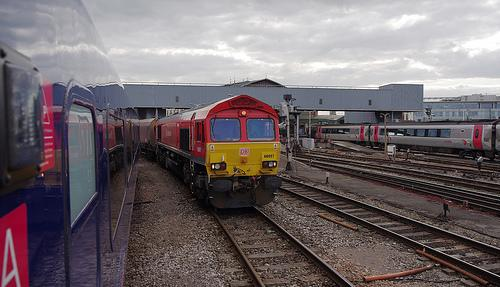List down at least three objects in the image that are associated with the train tracks. Rocks on the track, sets of train tracks, and stones around the tracks. What can be said about the positioning of the trains in the image? Many trains are in the station, with three of them visible in the image. Identify an object in the image that is turned on. The lights on the side of the train are turned on. What type of building is depicted in the image? A long building over the train tracks, which appears to be a train station. What is the primary object in the picture and what is its color? The primary object in the image is a red and yellow train. Count the number of train tracks visible in the image. There are multiple sets of train tracks in the station. Can you describe any distinct feature or detail related to the train's appearance? The train has a pair of small headlights and red doors. Explain the location of the red object in the image. The red object is a door located on the side of the train. In a few words, describe the weather conditions depicted in the image. The weather in the image is overcast with a very cloudy grey sky. In a brief sentence, describe the overall sentiment or mood of the image. The image captures a busy train station on an overcast day. Are the lights on the side of the train off? There is a mention of the lights on the side being on, but no mentions of the lights being off. Is the train blue and green? There are several mentions of the train being red and yellow, but none of the train being blue and green. Is there only one train track in the station? There are many mentions of sets of train tracks and multiple train tracks in the station, but no mention of only one train track. Is the sky clear and sunny? There are several mentions of the sky being overcast, cloudy, and grey, but none of the sky being clear and sunny. Are there no windows on the train? There are mentions of a row of windows, a pair of windows at the front of the train, and windows on train cars. There are no mentions of a train without windows. Is the door on the train green? There is a mention of the door being red, and the train being red and yellow, but no mentions of a green door. 